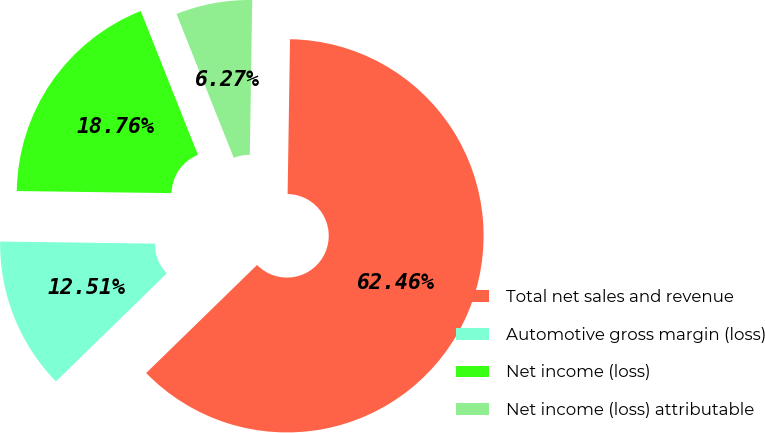Convert chart. <chart><loc_0><loc_0><loc_500><loc_500><pie_chart><fcel>Total net sales and revenue<fcel>Automotive gross margin (loss)<fcel>Net income (loss)<fcel>Net income (loss) attributable<nl><fcel>62.46%<fcel>12.51%<fcel>18.76%<fcel>6.27%<nl></chart> 